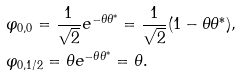Convert formula to latex. <formula><loc_0><loc_0><loc_500><loc_500>& \varphi _ { 0 , 0 } = \frac { 1 } { \sqrt { 2 } } e ^ { - \theta \theta ^ { * } } = \frac { 1 } { \sqrt { 2 } } ( 1 - \theta \theta ^ { * } ) , \\ & \varphi _ { 0 , 1 / 2 } = \theta e ^ { - \theta \theta ^ { * } } = \theta .</formula> 